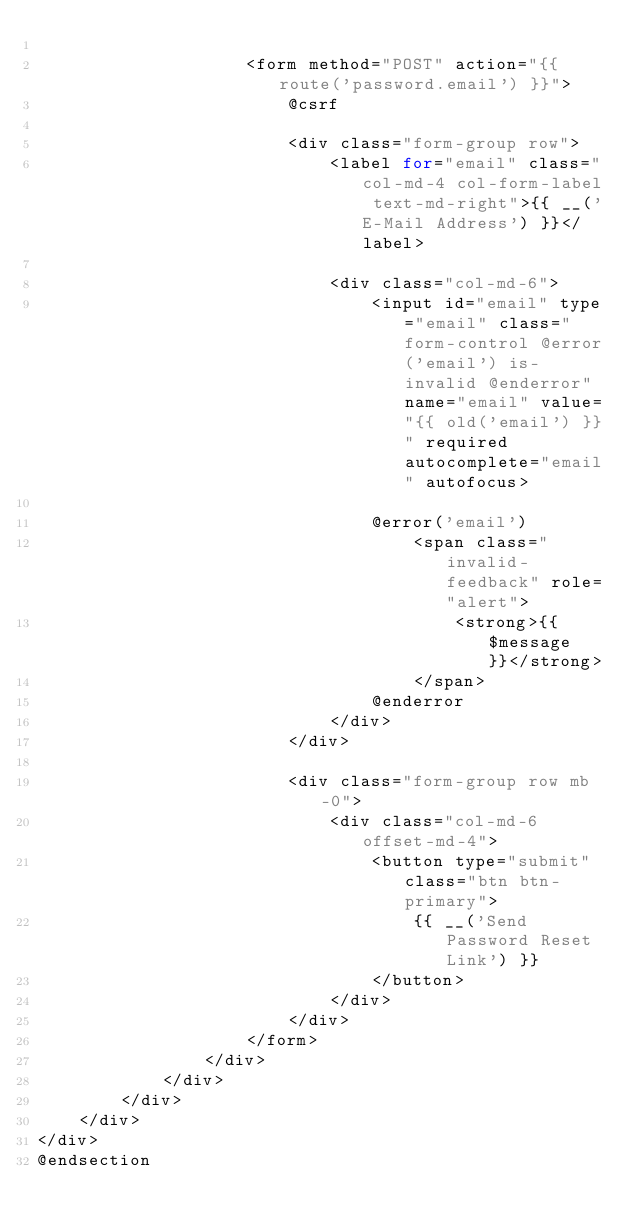Convert code to text. <code><loc_0><loc_0><loc_500><loc_500><_PHP_>
                    <form method="POST" action="{{ route('password.email') }}">
                        @csrf

                        <div class="form-group row">
                            <label for="email" class="col-md-4 col-form-label text-md-right">{{ __('E-Mail Address') }}</label>

                            <div class="col-md-6">
                                <input id="email" type="email" class="form-control @error('email') is-invalid @enderror" name="email" value="{{ old('email') }}" required autocomplete="email" autofocus>

                                @error('email')
                                    <span class="invalid-feedback" role="alert">
                                        <strong>{{ $message }}</strong>
                                    </span>
                                @enderror
                            </div>
                        </div>

                        <div class="form-group row mb-0">
                            <div class="col-md-6 offset-md-4">
                                <button type="submit" class="btn btn-primary">
                                    {{ __('Send Password Reset Link') }}
                                </button>
                            </div>
                        </div>
                    </form>
                </div>
            </div>
        </div>
    </div>
</div>
@endsection
</code> 